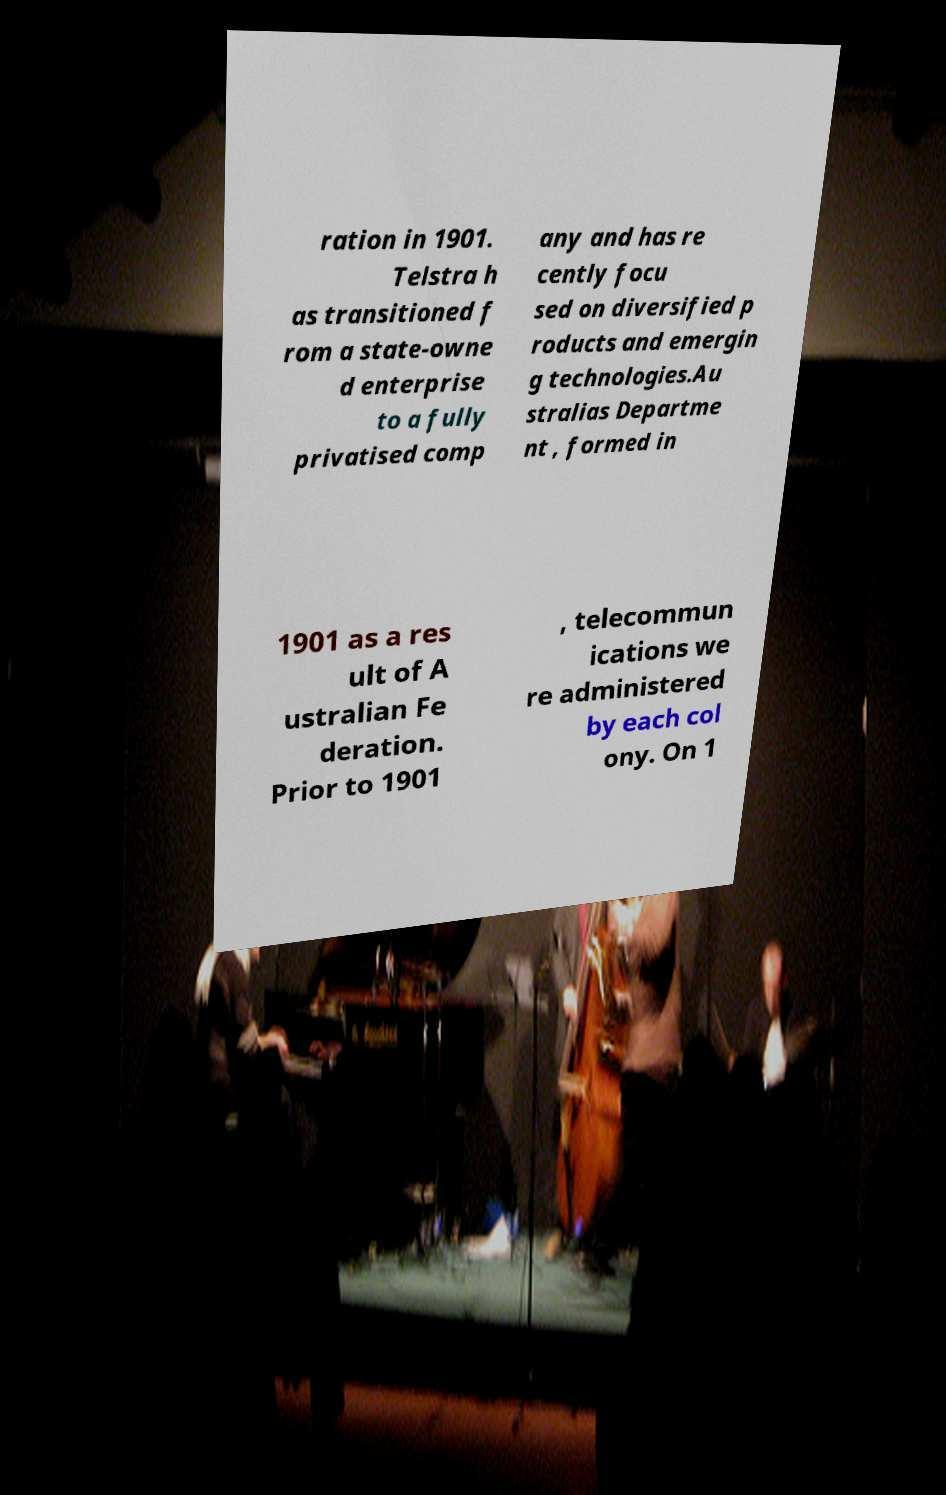What messages or text are displayed in this image? I need them in a readable, typed format. ration in 1901. Telstra h as transitioned f rom a state-owne d enterprise to a fully privatised comp any and has re cently focu sed on diversified p roducts and emergin g technologies.Au stralias Departme nt , formed in 1901 as a res ult of A ustralian Fe deration. Prior to 1901 , telecommun ications we re administered by each col ony. On 1 